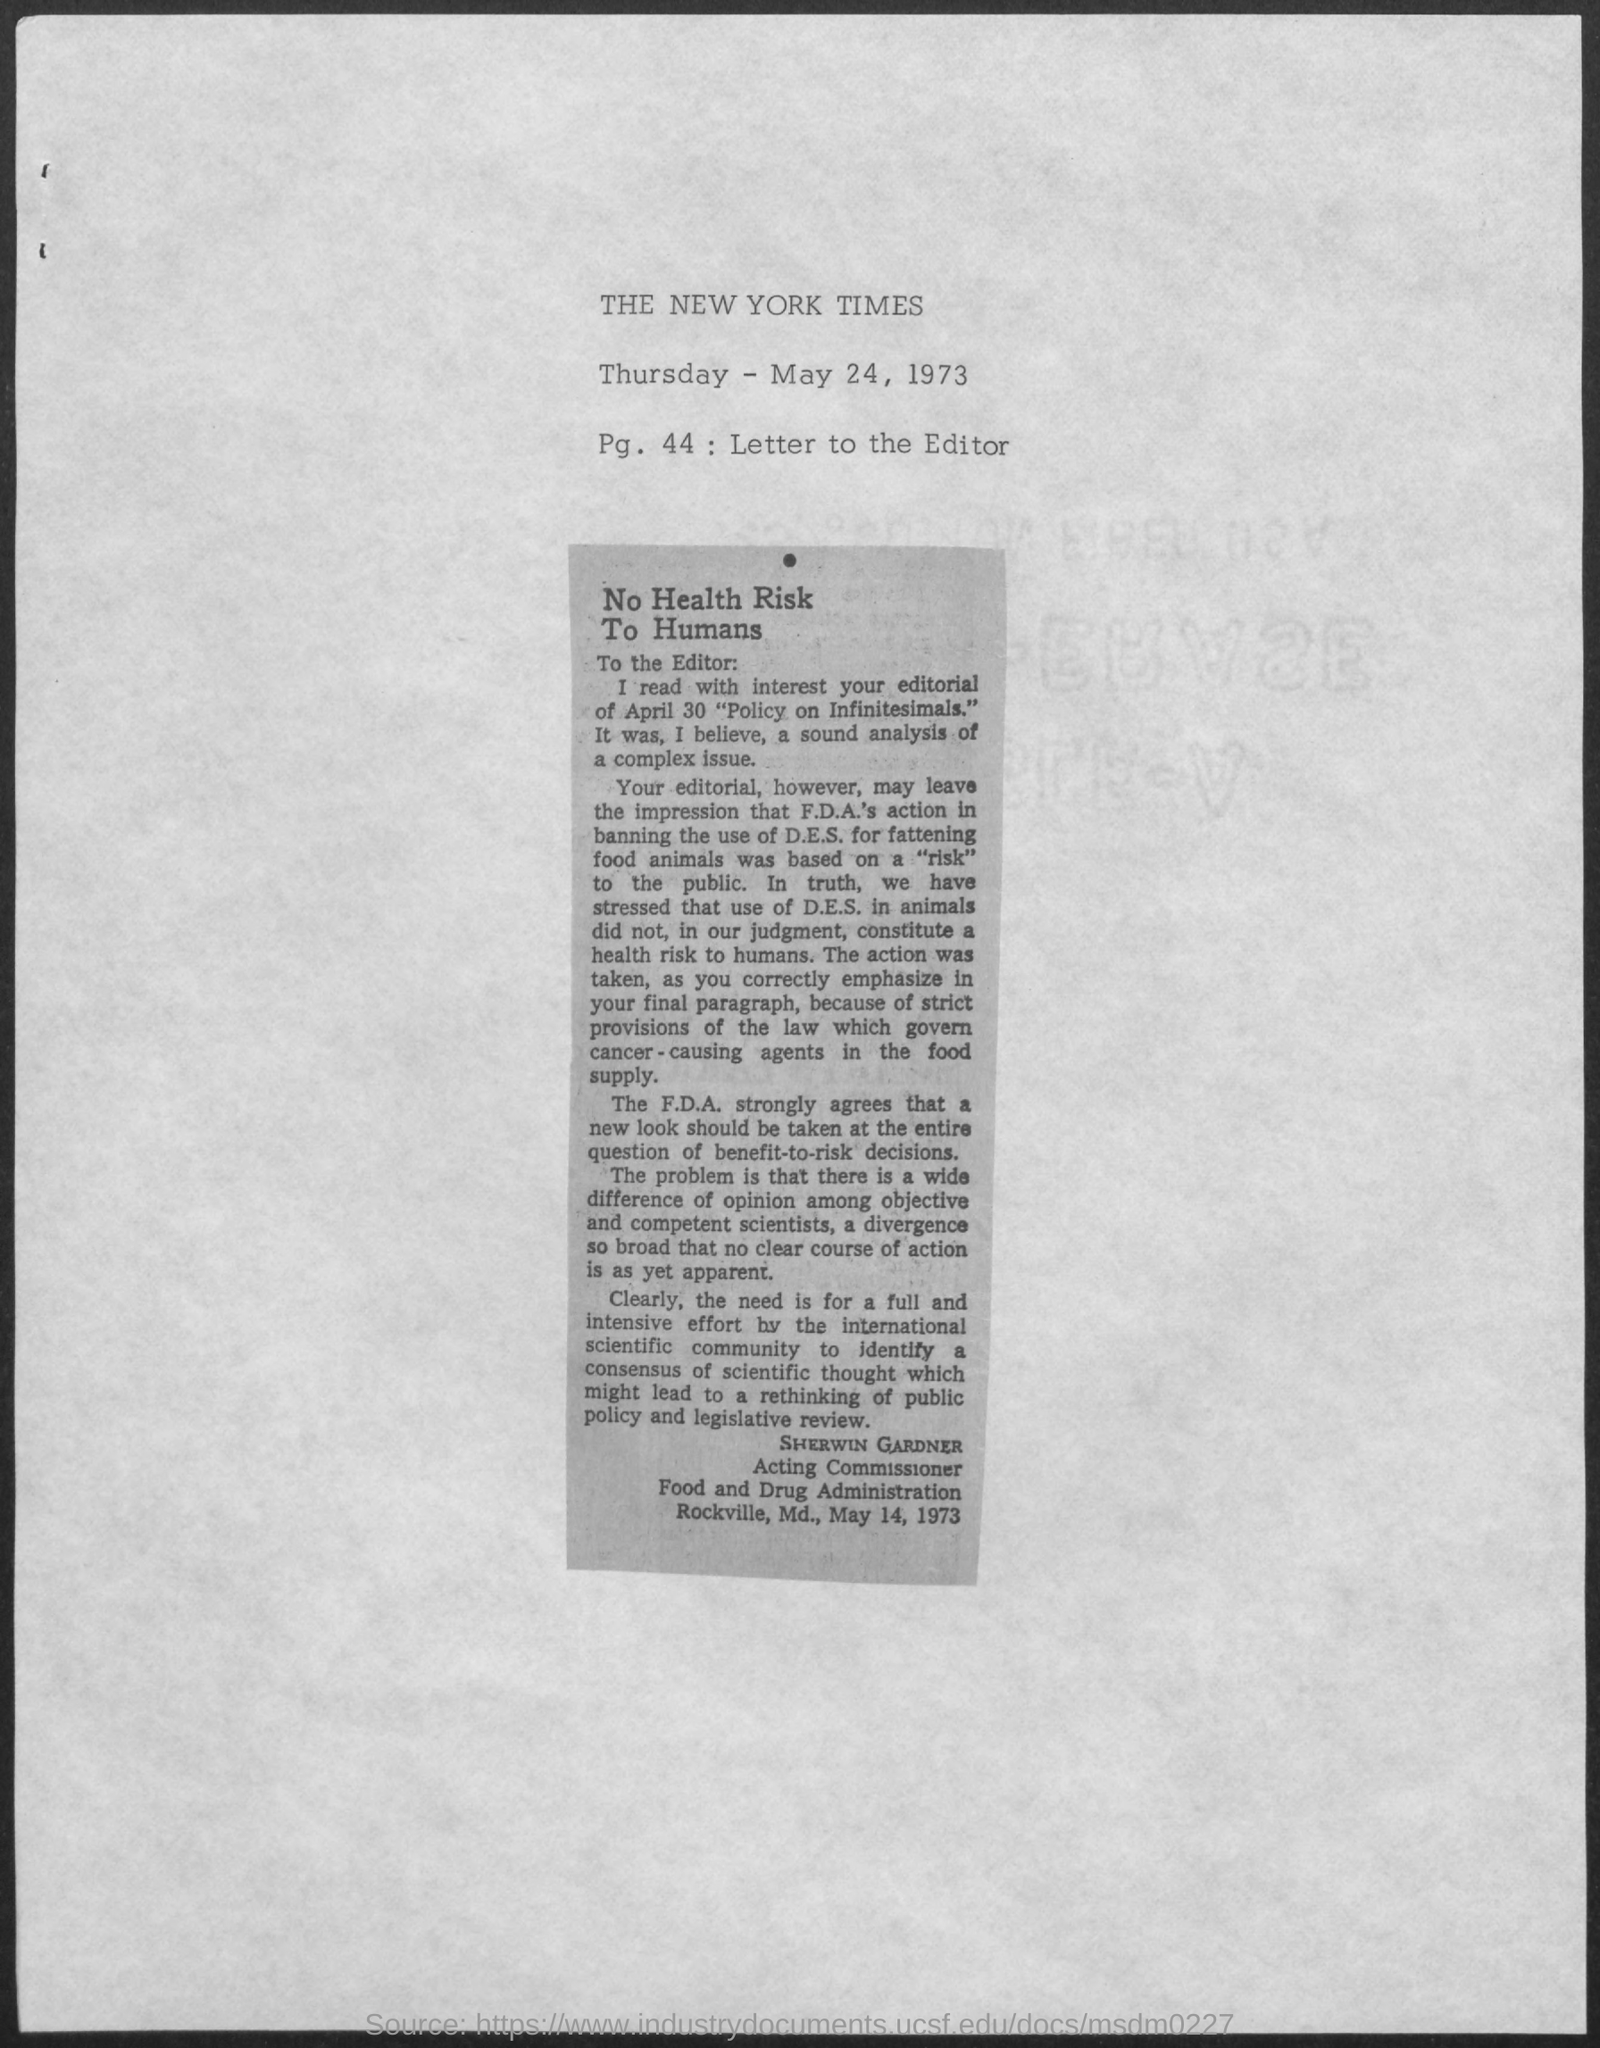What is the Title of the document?
Keep it short and to the point. The New York Times. What is the date on the document?
Ensure brevity in your answer.  Thursday - May 24, 1973. 